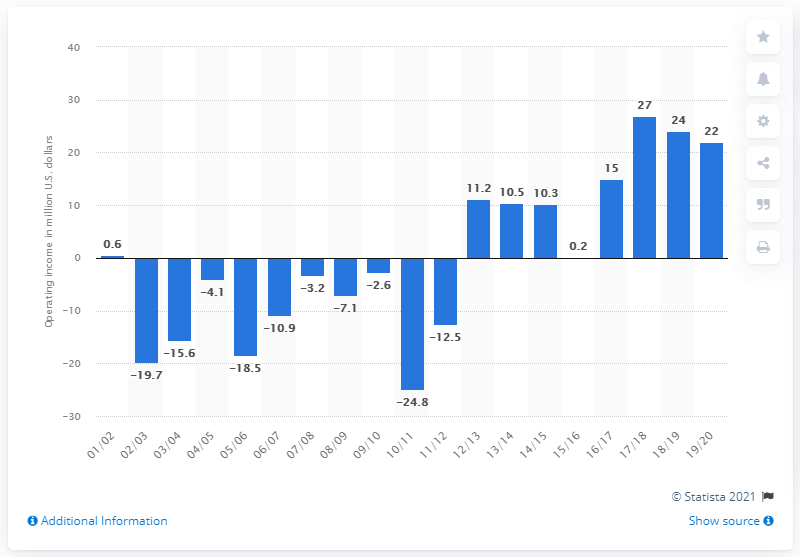Indicate a few pertinent items in this graphic. The operating income of the Memphis Grizzlies in the 2019/20 season was $22 million. 